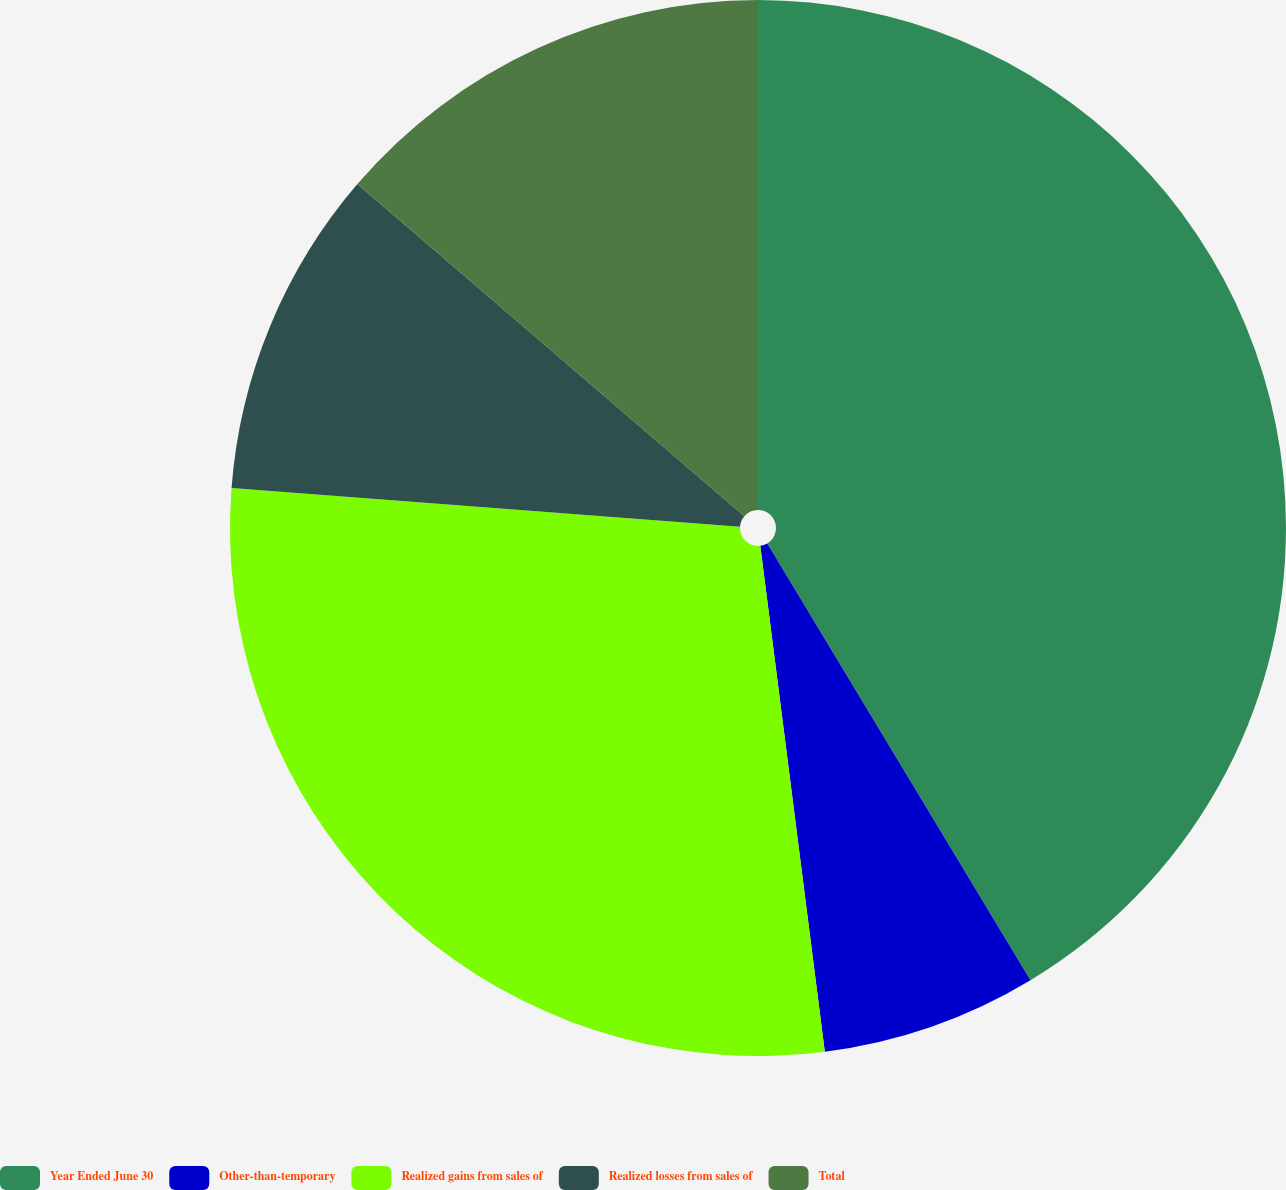<chart> <loc_0><loc_0><loc_500><loc_500><pie_chart><fcel>Year Ended June 30<fcel>Other-than-temporary<fcel>Realized gains from sales of<fcel>Realized losses from sales of<fcel>Total<nl><fcel>41.37%<fcel>6.61%<fcel>28.23%<fcel>10.08%<fcel>13.71%<nl></chart> 